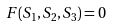<formula> <loc_0><loc_0><loc_500><loc_500>F ( S _ { 1 } , S _ { 2 } , S _ { 3 } ) = 0</formula> 